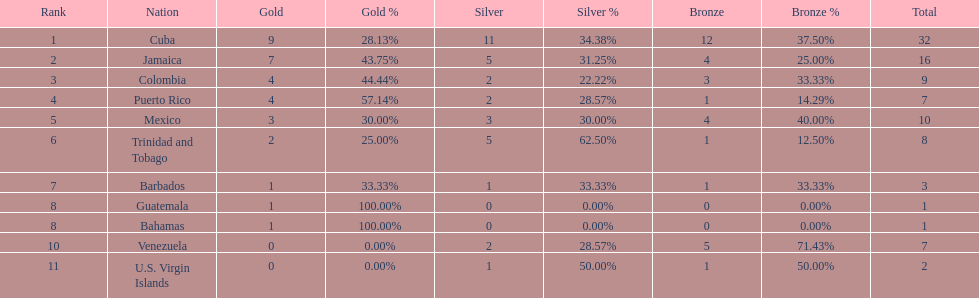Only team to have more than 30 medals Cuba. 